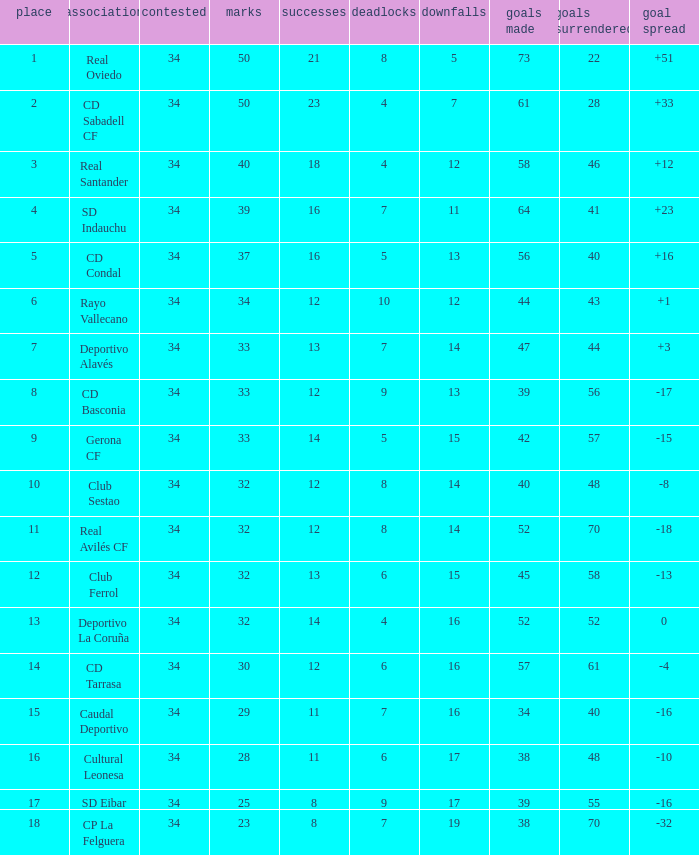Which Played has Draws smaller than 7, and Goals for smaller than 61, and Goals against smaller than 48, and a Position of 5? 34.0. 